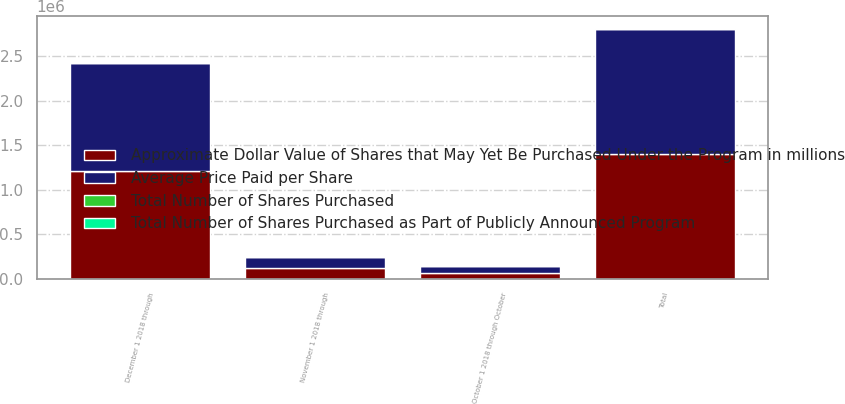Convert chart. <chart><loc_0><loc_0><loc_500><loc_500><stacked_bar_chart><ecel><fcel>October 1 2018 through October<fcel>November 1 2018 through<fcel>December 1 2018 through<fcel>Total<nl><fcel>Average Price Paid per Share<fcel>69516<fcel>122406<fcel>1.21136e+06<fcel>1.40329e+06<nl><fcel>Total Number of Shares Purchased as Part of Publicly Announced Program<fcel>239.71<fcel>215.4<fcel>192.19<fcel>196.57<nl><fcel>Approximate Dollar Value of Shares that May Yet Be Purchased Under the Program in millions<fcel>69516<fcel>122406<fcel>1.21136e+06<fcel>1.40329e+06<nl><fcel>Total Number of Shares Purchased<fcel>699.7<fcel>673.3<fcel>440.5<fcel>440.5<nl></chart> 